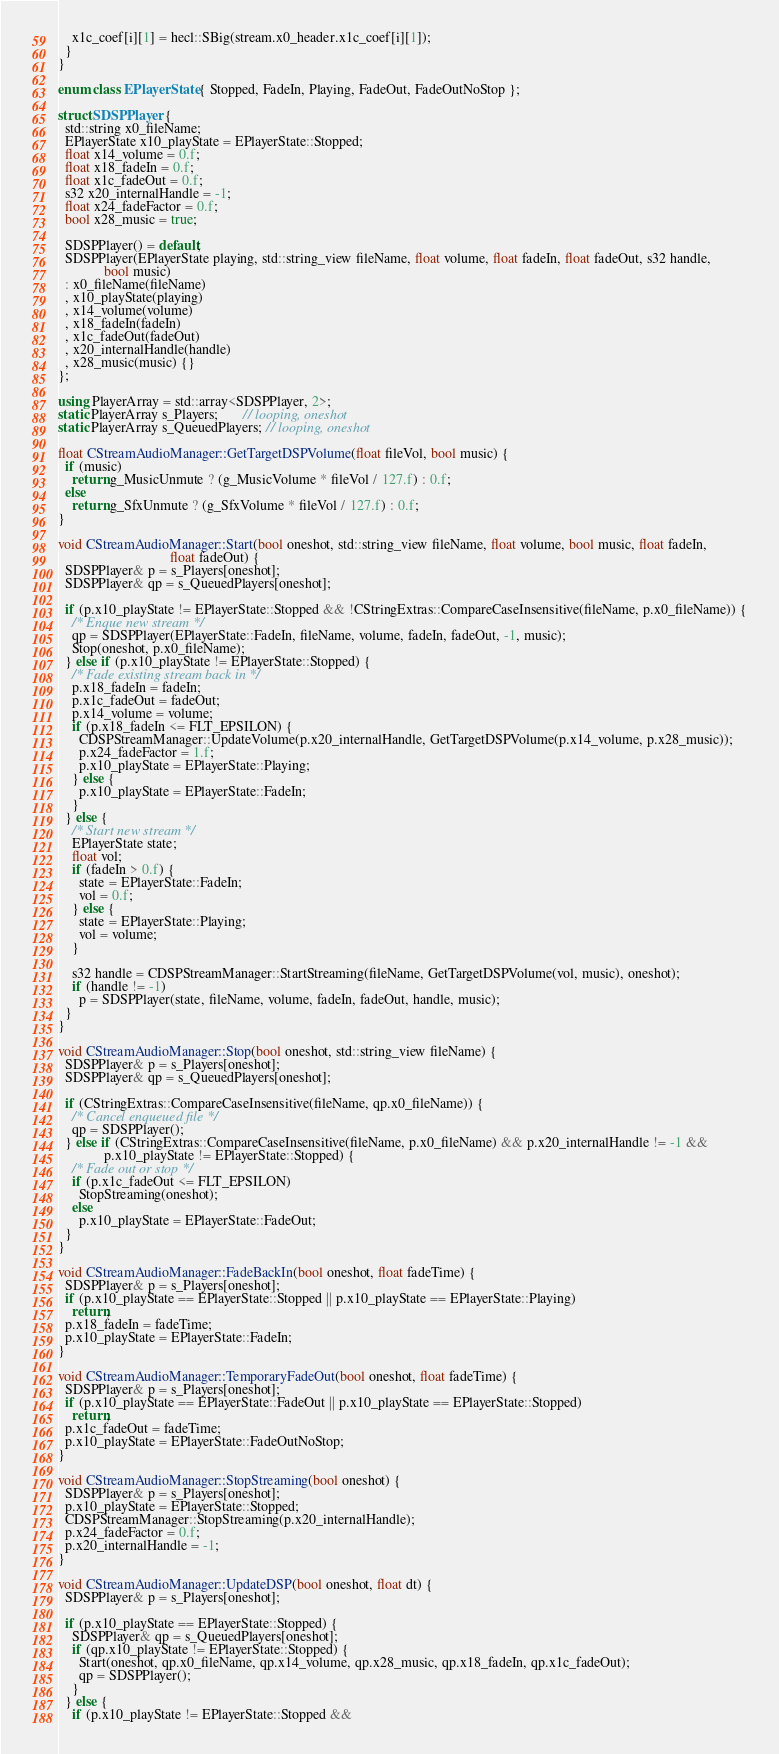<code> <loc_0><loc_0><loc_500><loc_500><_C++_>    x1c_coef[i][1] = hecl::SBig(stream.x0_header.x1c_coef[i][1]);
  }
}

enum class EPlayerState { Stopped, FadeIn, Playing, FadeOut, FadeOutNoStop };

struct SDSPPlayer {
  std::string x0_fileName;
  EPlayerState x10_playState = EPlayerState::Stopped;
  float x14_volume = 0.f;
  float x18_fadeIn = 0.f;
  float x1c_fadeOut = 0.f;
  s32 x20_internalHandle = -1;
  float x24_fadeFactor = 0.f;
  bool x28_music = true;

  SDSPPlayer() = default;
  SDSPPlayer(EPlayerState playing, std::string_view fileName, float volume, float fadeIn, float fadeOut, s32 handle,
             bool music)
  : x0_fileName(fileName)
  , x10_playState(playing)
  , x14_volume(volume)
  , x18_fadeIn(fadeIn)
  , x1c_fadeOut(fadeOut)
  , x20_internalHandle(handle)
  , x28_music(music) {}
};

using PlayerArray = std::array<SDSPPlayer, 2>;
static PlayerArray s_Players;       // looping, oneshot
static PlayerArray s_QueuedPlayers; // looping, oneshot

float CStreamAudioManager::GetTargetDSPVolume(float fileVol, bool music) {
  if (music)
    return g_MusicUnmute ? (g_MusicVolume * fileVol / 127.f) : 0.f;
  else
    return g_SfxUnmute ? (g_SfxVolume * fileVol / 127.f) : 0.f;
}

void CStreamAudioManager::Start(bool oneshot, std::string_view fileName, float volume, bool music, float fadeIn,
                                float fadeOut) {
  SDSPPlayer& p = s_Players[oneshot];
  SDSPPlayer& qp = s_QueuedPlayers[oneshot];

  if (p.x10_playState != EPlayerState::Stopped && !CStringExtras::CompareCaseInsensitive(fileName, p.x0_fileName)) {
    /* Enque new stream */
    qp = SDSPPlayer(EPlayerState::FadeIn, fileName, volume, fadeIn, fadeOut, -1, music);
    Stop(oneshot, p.x0_fileName);
  } else if (p.x10_playState != EPlayerState::Stopped) {
    /* Fade existing stream back in */
    p.x18_fadeIn = fadeIn;
    p.x1c_fadeOut = fadeOut;
    p.x14_volume = volume;
    if (p.x18_fadeIn <= FLT_EPSILON) {
      CDSPStreamManager::UpdateVolume(p.x20_internalHandle, GetTargetDSPVolume(p.x14_volume, p.x28_music));
      p.x24_fadeFactor = 1.f;
      p.x10_playState = EPlayerState::Playing;
    } else {
      p.x10_playState = EPlayerState::FadeIn;
    }
  } else {
    /* Start new stream */
    EPlayerState state;
    float vol;
    if (fadeIn > 0.f) {
      state = EPlayerState::FadeIn;
      vol = 0.f;
    } else {
      state = EPlayerState::Playing;
      vol = volume;
    }

    s32 handle = CDSPStreamManager::StartStreaming(fileName, GetTargetDSPVolume(vol, music), oneshot);
    if (handle != -1)
      p = SDSPPlayer(state, fileName, volume, fadeIn, fadeOut, handle, music);
  }
}

void CStreamAudioManager::Stop(bool oneshot, std::string_view fileName) {
  SDSPPlayer& p = s_Players[oneshot];
  SDSPPlayer& qp = s_QueuedPlayers[oneshot];

  if (CStringExtras::CompareCaseInsensitive(fileName, qp.x0_fileName)) {
    /* Cancel enqueued file */
    qp = SDSPPlayer();
  } else if (CStringExtras::CompareCaseInsensitive(fileName, p.x0_fileName) && p.x20_internalHandle != -1 &&
             p.x10_playState != EPlayerState::Stopped) {
    /* Fade out or stop */
    if (p.x1c_fadeOut <= FLT_EPSILON)
      StopStreaming(oneshot);
    else
      p.x10_playState = EPlayerState::FadeOut;
  }
}

void CStreamAudioManager::FadeBackIn(bool oneshot, float fadeTime) {
  SDSPPlayer& p = s_Players[oneshot];
  if (p.x10_playState == EPlayerState::Stopped || p.x10_playState == EPlayerState::Playing)
    return;
  p.x18_fadeIn = fadeTime;
  p.x10_playState = EPlayerState::FadeIn;
}

void CStreamAudioManager::TemporaryFadeOut(bool oneshot, float fadeTime) {
  SDSPPlayer& p = s_Players[oneshot];
  if (p.x10_playState == EPlayerState::FadeOut || p.x10_playState == EPlayerState::Stopped)
    return;
  p.x1c_fadeOut = fadeTime;
  p.x10_playState = EPlayerState::FadeOutNoStop;
}

void CStreamAudioManager::StopStreaming(bool oneshot) {
  SDSPPlayer& p = s_Players[oneshot];
  p.x10_playState = EPlayerState::Stopped;
  CDSPStreamManager::StopStreaming(p.x20_internalHandle);
  p.x24_fadeFactor = 0.f;
  p.x20_internalHandle = -1;
}

void CStreamAudioManager::UpdateDSP(bool oneshot, float dt) {
  SDSPPlayer& p = s_Players[oneshot];

  if (p.x10_playState == EPlayerState::Stopped) {
    SDSPPlayer& qp = s_QueuedPlayers[oneshot];
    if (qp.x10_playState != EPlayerState::Stopped) {
      Start(oneshot, qp.x0_fileName, qp.x14_volume, qp.x28_music, qp.x18_fadeIn, qp.x1c_fadeOut);
      qp = SDSPPlayer();
    }
  } else {
    if (p.x10_playState != EPlayerState::Stopped &&</code> 